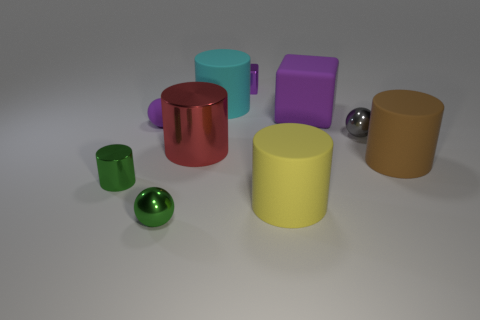Subtract all gray metallic balls. How many balls are left? 2 Subtract all green cylinders. How many cylinders are left? 4 Subtract all yellow spheres. Subtract all gray cubes. How many spheres are left? 3 Subtract all cubes. How many objects are left? 8 Subtract all tiny brown objects. Subtract all brown rubber objects. How many objects are left? 9 Add 8 large purple cubes. How many large purple cubes are left? 9 Add 6 gray shiny blocks. How many gray shiny blocks exist? 6 Subtract 0 cyan blocks. How many objects are left? 10 